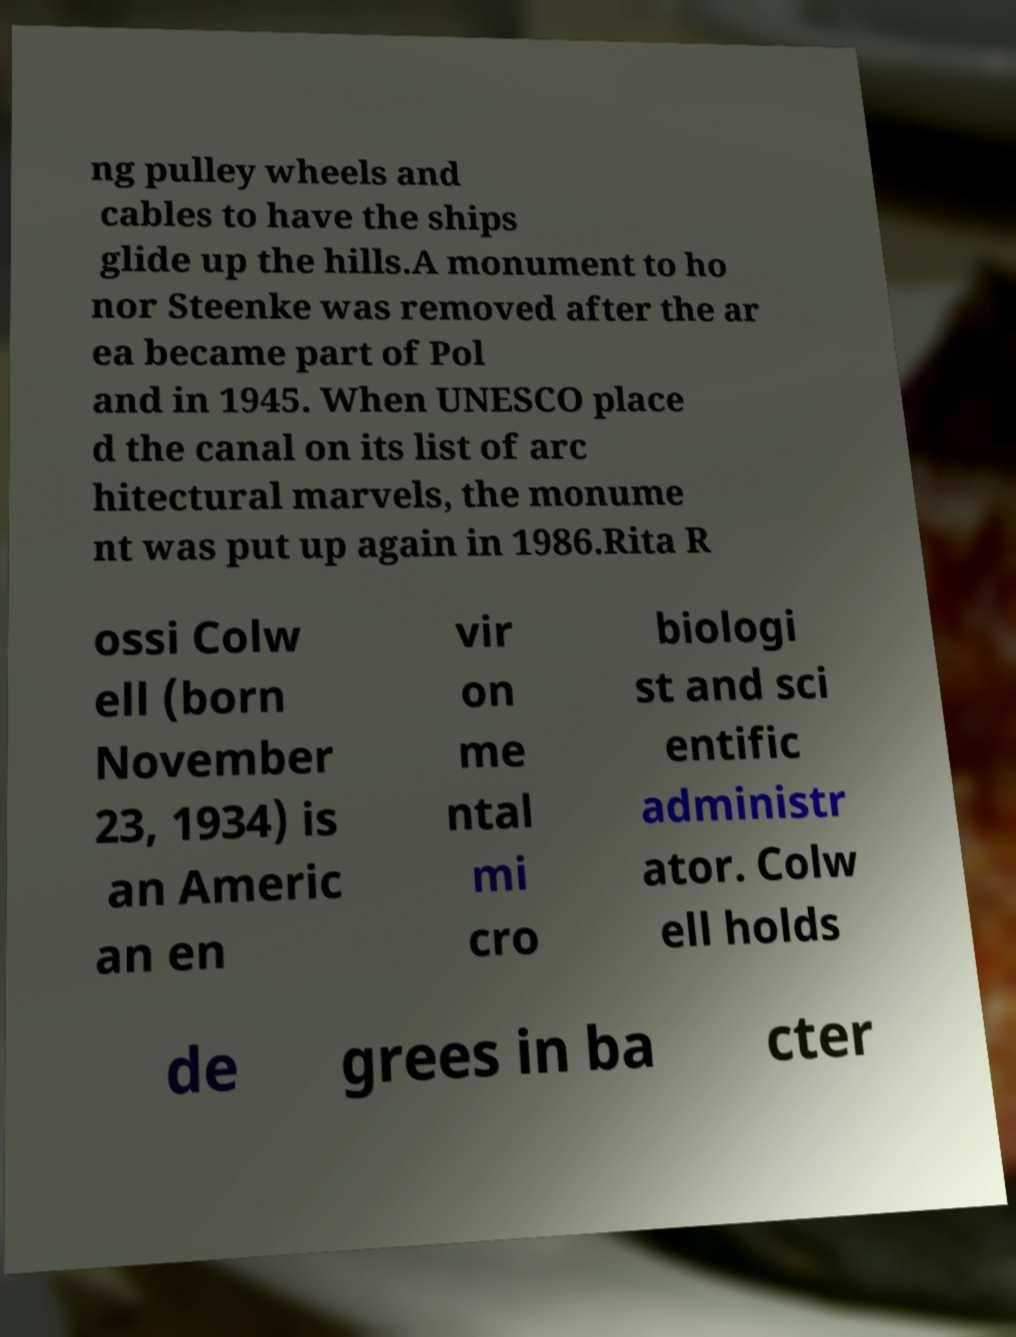Can you accurately transcribe the text from the provided image for me? ng pulley wheels and cables to have the ships glide up the hills.A monument to ho nor Steenke was removed after the ar ea became part of Pol and in 1945. When UNESCO place d the canal on its list of arc hitectural marvels, the monume nt was put up again in 1986.Rita R ossi Colw ell (born November 23, 1934) is an Americ an en vir on me ntal mi cro biologi st and sci entific administr ator. Colw ell holds de grees in ba cter 